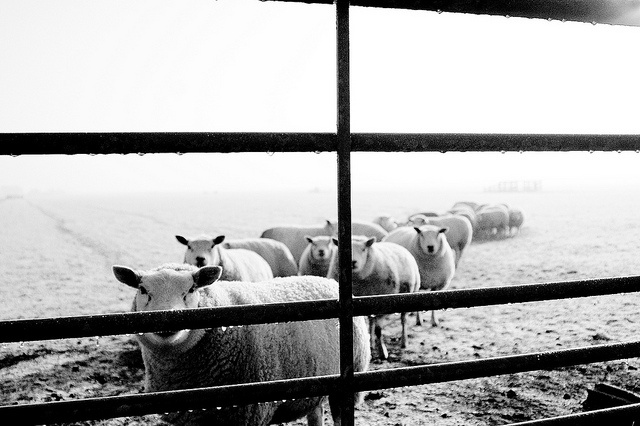Describe the objects in this image and their specific colors. I can see sheep in white, black, gray, lightgray, and darkgray tones, sheep in white, lightgray, darkgray, black, and gray tones, sheep in white, gray, darkgray, lightgray, and black tones, sheep in white, lightgray, darkgray, gray, and black tones, and sheep in white, darkgray, gray, black, and lightgray tones in this image. 